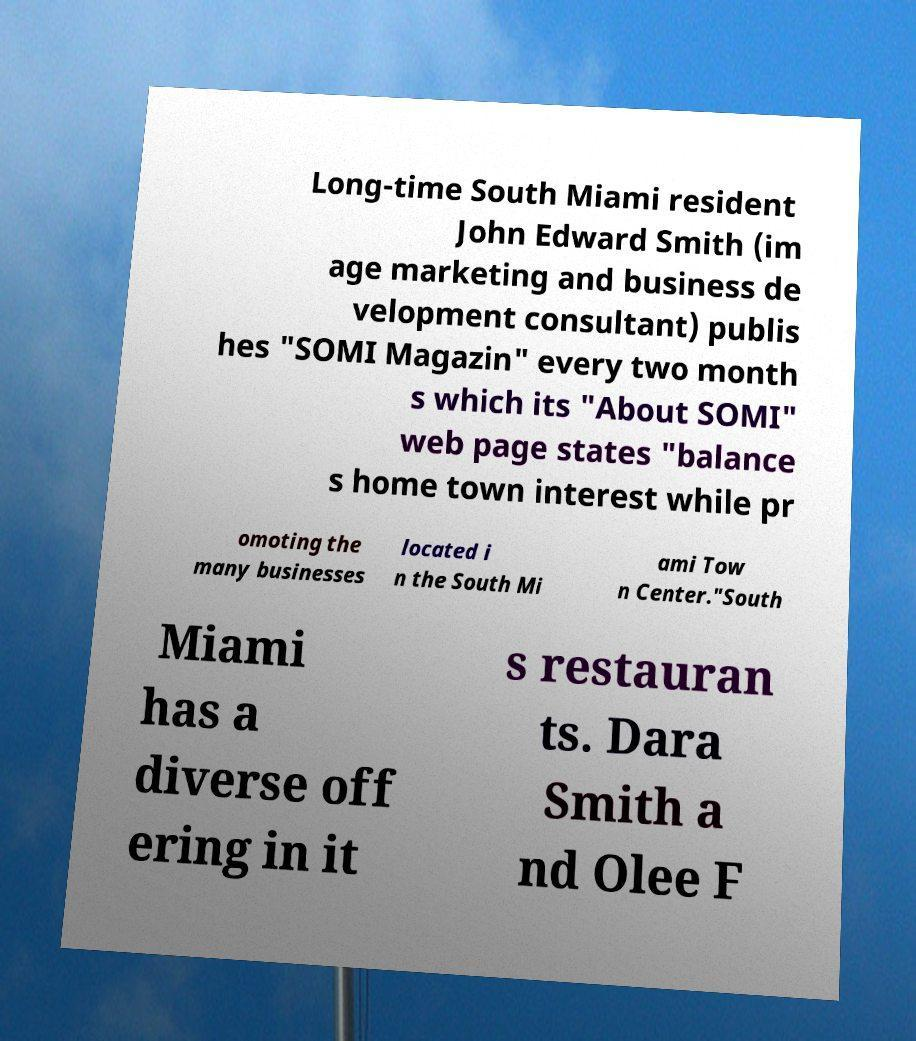Can you accurately transcribe the text from the provided image for me? Long-time South Miami resident John Edward Smith (im age marketing and business de velopment consultant) publis hes "SOMI Magazin" every two month s which its "About SOMI" web page states "balance s home town interest while pr omoting the many businesses located i n the South Mi ami Tow n Center."South Miami has a diverse off ering in it s restauran ts. Dara Smith a nd Olee F 